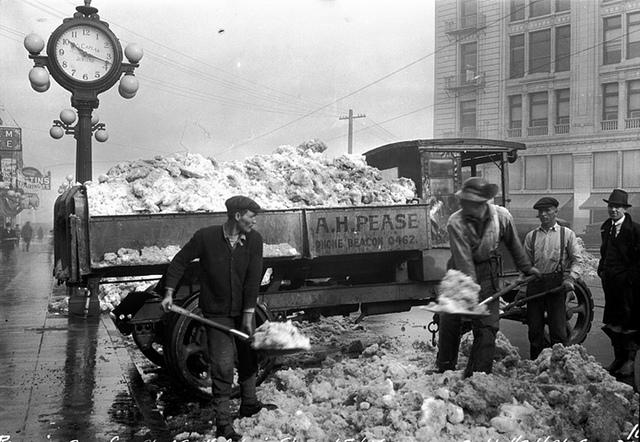What country is this?
Give a very brief answer. Usa. Are these men working?
Give a very brief answer. Yes. Are all the men pictured wearing hats?
Short answer required. Yes. What is the time the men are shoveling snow?
Concise answer only. 10:20. 